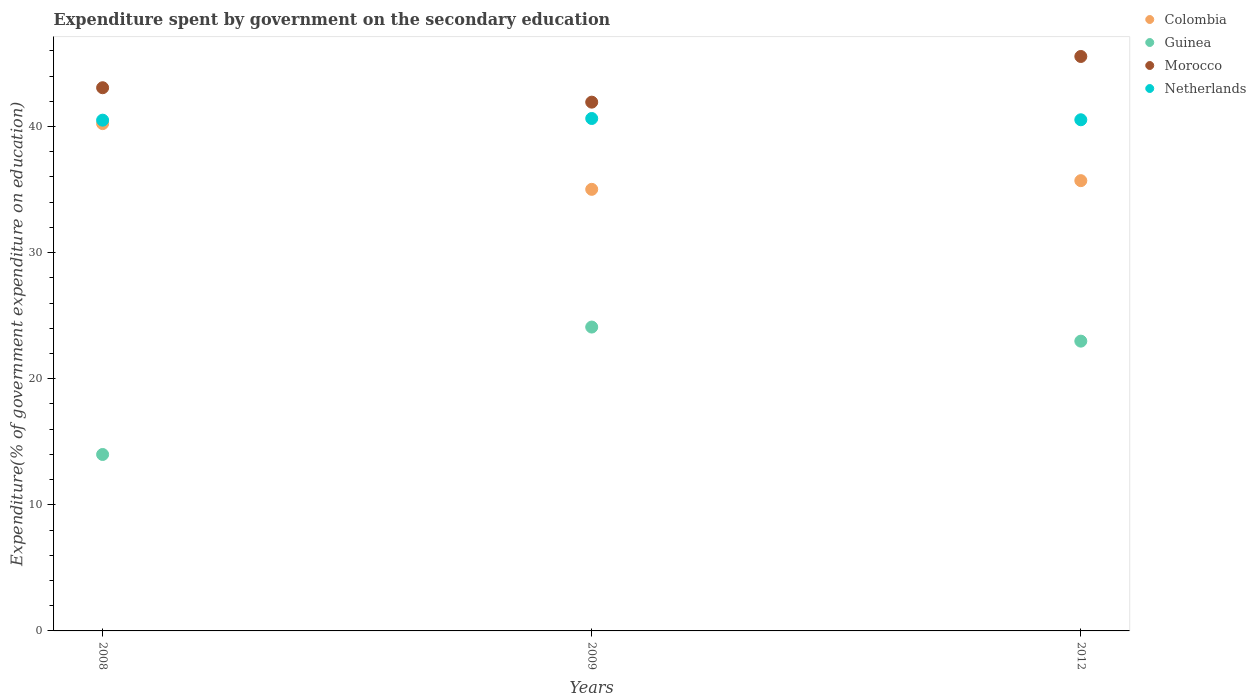Is the number of dotlines equal to the number of legend labels?
Your answer should be very brief. Yes. What is the expenditure spent by government on the secondary education in Morocco in 2009?
Provide a succinct answer. 41.93. Across all years, what is the maximum expenditure spent by government on the secondary education in Colombia?
Offer a terse response. 40.23. Across all years, what is the minimum expenditure spent by government on the secondary education in Netherlands?
Offer a very short reply. 40.5. In which year was the expenditure spent by government on the secondary education in Colombia maximum?
Offer a very short reply. 2008. In which year was the expenditure spent by government on the secondary education in Morocco minimum?
Offer a very short reply. 2009. What is the total expenditure spent by government on the secondary education in Netherlands in the graph?
Your answer should be compact. 121.66. What is the difference between the expenditure spent by government on the secondary education in Morocco in 2008 and that in 2012?
Ensure brevity in your answer.  -2.48. What is the difference between the expenditure spent by government on the secondary education in Netherlands in 2012 and the expenditure spent by government on the secondary education in Guinea in 2008?
Give a very brief answer. 26.54. What is the average expenditure spent by government on the secondary education in Guinea per year?
Offer a very short reply. 20.35. In the year 2008, what is the difference between the expenditure spent by government on the secondary education in Netherlands and expenditure spent by government on the secondary education in Guinea?
Offer a very short reply. 26.51. What is the ratio of the expenditure spent by government on the secondary education in Guinea in 2008 to that in 2009?
Your answer should be very brief. 0.58. Is the expenditure spent by government on the secondary education in Netherlands in 2008 less than that in 2009?
Provide a short and direct response. Yes. What is the difference between the highest and the second highest expenditure spent by government on the secondary education in Netherlands?
Offer a very short reply. 0.1. What is the difference between the highest and the lowest expenditure spent by government on the secondary education in Morocco?
Provide a short and direct response. 3.62. Is the sum of the expenditure spent by government on the secondary education in Guinea in 2008 and 2012 greater than the maximum expenditure spent by government on the secondary education in Colombia across all years?
Your response must be concise. No. Is the expenditure spent by government on the secondary education in Colombia strictly greater than the expenditure spent by government on the secondary education in Morocco over the years?
Your answer should be compact. No. What is the difference between two consecutive major ticks on the Y-axis?
Your answer should be compact. 10. Does the graph contain any zero values?
Your answer should be very brief. No. Does the graph contain grids?
Your response must be concise. No. Where does the legend appear in the graph?
Offer a terse response. Top right. What is the title of the graph?
Your answer should be very brief. Expenditure spent by government on the secondary education. What is the label or title of the X-axis?
Keep it short and to the point. Years. What is the label or title of the Y-axis?
Provide a short and direct response. Expenditure(% of government expenditure on education). What is the Expenditure(% of government expenditure on education) of Colombia in 2008?
Ensure brevity in your answer.  40.23. What is the Expenditure(% of government expenditure on education) of Guinea in 2008?
Your answer should be very brief. 13.99. What is the Expenditure(% of government expenditure on education) in Morocco in 2008?
Offer a very short reply. 43.07. What is the Expenditure(% of government expenditure on education) of Netherlands in 2008?
Provide a short and direct response. 40.5. What is the Expenditure(% of government expenditure on education) in Colombia in 2009?
Ensure brevity in your answer.  35.01. What is the Expenditure(% of government expenditure on education) in Guinea in 2009?
Ensure brevity in your answer.  24.09. What is the Expenditure(% of government expenditure on education) in Morocco in 2009?
Your answer should be compact. 41.93. What is the Expenditure(% of government expenditure on education) in Netherlands in 2009?
Your response must be concise. 40.63. What is the Expenditure(% of government expenditure on education) of Colombia in 2012?
Provide a succinct answer. 35.7. What is the Expenditure(% of government expenditure on education) of Guinea in 2012?
Offer a terse response. 22.98. What is the Expenditure(% of government expenditure on education) of Morocco in 2012?
Keep it short and to the point. 45.55. What is the Expenditure(% of government expenditure on education) in Netherlands in 2012?
Keep it short and to the point. 40.53. Across all years, what is the maximum Expenditure(% of government expenditure on education) in Colombia?
Provide a short and direct response. 40.23. Across all years, what is the maximum Expenditure(% of government expenditure on education) in Guinea?
Give a very brief answer. 24.09. Across all years, what is the maximum Expenditure(% of government expenditure on education) in Morocco?
Your response must be concise. 45.55. Across all years, what is the maximum Expenditure(% of government expenditure on education) in Netherlands?
Offer a very short reply. 40.63. Across all years, what is the minimum Expenditure(% of government expenditure on education) in Colombia?
Give a very brief answer. 35.01. Across all years, what is the minimum Expenditure(% of government expenditure on education) in Guinea?
Your answer should be very brief. 13.99. Across all years, what is the minimum Expenditure(% of government expenditure on education) in Morocco?
Your answer should be compact. 41.93. Across all years, what is the minimum Expenditure(% of government expenditure on education) of Netherlands?
Your answer should be very brief. 40.5. What is the total Expenditure(% of government expenditure on education) in Colombia in the graph?
Keep it short and to the point. 110.94. What is the total Expenditure(% of government expenditure on education) in Guinea in the graph?
Keep it short and to the point. 61.06. What is the total Expenditure(% of government expenditure on education) of Morocco in the graph?
Offer a very short reply. 130.55. What is the total Expenditure(% of government expenditure on education) in Netherlands in the graph?
Your response must be concise. 121.66. What is the difference between the Expenditure(% of government expenditure on education) of Colombia in 2008 and that in 2009?
Your answer should be very brief. 5.21. What is the difference between the Expenditure(% of government expenditure on education) of Guinea in 2008 and that in 2009?
Keep it short and to the point. -10.1. What is the difference between the Expenditure(% of government expenditure on education) of Morocco in 2008 and that in 2009?
Offer a very short reply. 1.14. What is the difference between the Expenditure(% of government expenditure on education) in Netherlands in 2008 and that in 2009?
Provide a succinct answer. -0.13. What is the difference between the Expenditure(% of government expenditure on education) in Colombia in 2008 and that in 2012?
Your answer should be very brief. 4.52. What is the difference between the Expenditure(% of government expenditure on education) of Guinea in 2008 and that in 2012?
Provide a short and direct response. -8.99. What is the difference between the Expenditure(% of government expenditure on education) in Morocco in 2008 and that in 2012?
Make the answer very short. -2.48. What is the difference between the Expenditure(% of government expenditure on education) of Netherlands in 2008 and that in 2012?
Your response must be concise. -0.03. What is the difference between the Expenditure(% of government expenditure on education) of Colombia in 2009 and that in 2012?
Your answer should be compact. -0.69. What is the difference between the Expenditure(% of government expenditure on education) of Guinea in 2009 and that in 2012?
Offer a terse response. 1.12. What is the difference between the Expenditure(% of government expenditure on education) of Morocco in 2009 and that in 2012?
Your answer should be very brief. -3.62. What is the difference between the Expenditure(% of government expenditure on education) of Netherlands in 2009 and that in 2012?
Provide a succinct answer. 0.1. What is the difference between the Expenditure(% of government expenditure on education) in Colombia in 2008 and the Expenditure(% of government expenditure on education) in Guinea in 2009?
Offer a terse response. 16.13. What is the difference between the Expenditure(% of government expenditure on education) in Colombia in 2008 and the Expenditure(% of government expenditure on education) in Morocco in 2009?
Keep it short and to the point. -1.7. What is the difference between the Expenditure(% of government expenditure on education) of Colombia in 2008 and the Expenditure(% of government expenditure on education) of Netherlands in 2009?
Keep it short and to the point. -0.41. What is the difference between the Expenditure(% of government expenditure on education) in Guinea in 2008 and the Expenditure(% of government expenditure on education) in Morocco in 2009?
Your response must be concise. -27.94. What is the difference between the Expenditure(% of government expenditure on education) in Guinea in 2008 and the Expenditure(% of government expenditure on education) in Netherlands in 2009?
Your response must be concise. -26.64. What is the difference between the Expenditure(% of government expenditure on education) in Morocco in 2008 and the Expenditure(% of government expenditure on education) in Netherlands in 2009?
Offer a terse response. 2.44. What is the difference between the Expenditure(% of government expenditure on education) in Colombia in 2008 and the Expenditure(% of government expenditure on education) in Guinea in 2012?
Your response must be concise. 17.25. What is the difference between the Expenditure(% of government expenditure on education) of Colombia in 2008 and the Expenditure(% of government expenditure on education) of Morocco in 2012?
Provide a succinct answer. -5.32. What is the difference between the Expenditure(% of government expenditure on education) in Colombia in 2008 and the Expenditure(% of government expenditure on education) in Netherlands in 2012?
Keep it short and to the point. -0.3. What is the difference between the Expenditure(% of government expenditure on education) of Guinea in 2008 and the Expenditure(% of government expenditure on education) of Morocco in 2012?
Your answer should be very brief. -31.56. What is the difference between the Expenditure(% of government expenditure on education) in Guinea in 2008 and the Expenditure(% of government expenditure on education) in Netherlands in 2012?
Ensure brevity in your answer.  -26.54. What is the difference between the Expenditure(% of government expenditure on education) of Morocco in 2008 and the Expenditure(% of government expenditure on education) of Netherlands in 2012?
Provide a succinct answer. 2.54. What is the difference between the Expenditure(% of government expenditure on education) of Colombia in 2009 and the Expenditure(% of government expenditure on education) of Guinea in 2012?
Your answer should be compact. 12.04. What is the difference between the Expenditure(% of government expenditure on education) of Colombia in 2009 and the Expenditure(% of government expenditure on education) of Morocco in 2012?
Your response must be concise. -10.54. What is the difference between the Expenditure(% of government expenditure on education) of Colombia in 2009 and the Expenditure(% of government expenditure on education) of Netherlands in 2012?
Offer a terse response. -5.52. What is the difference between the Expenditure(% of government expenditure on education) of Guinea in 2009 and the Expenditure(% of government expenditure on education) of Morocco in 2012?
Your answer should be compact. -21.46. What is the difference between the Expenditure(% of government expenditure on education) in Guinea in 2009 and the Expenditure(% of government expenditure on education) in Netherlands in 2012?
Give a very brief answer. -16.44. What is the difference between the Expenditure(% of government expenditure on education) of Morocco in 2009 and the Expenditure(% of government expenditure on education) of Netherlands in 2012?
Keep it short and to the point. 1.4. What is the average Expenditure(% of government expenditure on education) in Colombia per year?
Your response must be concise. 36.98. What is the average Expenditure(% of government expenditure on education) of Guinea per year?
Give a very brief answer. 20.35. What is the average Expenditure(% of government expenditure on education) in Morocco per year?
Give a very brief answer. 43.52. What is the average Expenditure(% of government expenditure on education) of Netherlands per year?
Your response must be concise. 40.55. In the year 2008, what is the difference between the Expenditure(% of government expenditure on education) of Colombia and Expenditure(% of government expenditure on education) of Guinea?
Offer a terse response. 26.24. In the year 2008, what is the difference between the Expenditure(% of government expenditure on education) of Colombia and Expenditure(% of government expenditure on education) of Morocco?
Give a very brief answer. -2.85. In the year 2008, what is the difference between the Expenditure(% of government expenditure on education) of Colombia and Expenditure(% of government expenditure on education) of Netherlands?
Provide a short and direct response. -0.27. In the year 2008, what is the difference between the Expenditure(% of government expenditure on education) of Guinea and Expenditure(% of government expenditure on education) of Morocco?
Your answer should be very brief. -29.08. In the year 2008, what is the difference between the Expenditure(% of government expenditure on education) of Guinea and Expenditure(% of government expenditure on education) of Netherlands?
Your response must be concise. -26.51. In the year 2008, what is the difference between the Expenditure(% of government expenditure on education) of Morocco and Expenditure(% of government expenditure on education) of Netherlands?
Offer a very short reply. 2.57. In the year 2009, what is the difference between the Expenditure(% of government expenditure on education) in Colombia and Expenditure(% of government expenditure on education) in Guinea?
Your answer should be compact. 10.92. In the year 2009, what is the difference between the Expenditure(% of government expenditure on education) in Colombia and Expenditure(% of government expenditure on education) in Morocco?
Offer a terse response. -6.91. In the year 2009, what is the difference between the Expenditure(% of government expenditure on education) in Colombia and Expenditure(% of government expenditure on education) in Netherlands?
Make the answer very short. -5.62. In the year 2009, what is the difference between the Expenditure(% of government expenditure on education) of Guinea and Expenditure(% of government expenditure on education) of Morocco?
Give a very brief answer. -17.83. In the year 2009, what is the difference between the Expenditure(% of government expenditure on education) in Guinea and Expenditure(% of government expenditure on education) in Netherlands?
Ensure brevity in your answer.  -16.54. In the year 2009, what is the difference between the Expenditure(% of government expenditure on education) of Morocco and Expenditure(% of government expenditure on education) of Netherlands?
Your answer should be very brief. 1.3. In the year 2012, what is the difference between the Expenditure(% of government expenditure on education) of Colombia and Expenditure(% of government expenditure on education) of Guinea?
Offer a terse response. 12.72. In the year 2012, what is the difference between the Expenditure(% of government expenditure on education) in Colombia and Expenditure(% of government expenditure on education) in Morocco?
Make the answer very short. -9.85. In the year 2012, what is the difference between the Expenditure(% of government expenditure on education) of Colombia and Expenditure(% of government expenditure on education) of Netherlands?
Give a very brief answer. -4.83. In the year 2012, what is the difference between the Expenditure(% of government expenditure on education) in Guinea and Expenditure(% of government expenditure on education) in Morocco?
Offer a very short reply. -22.57. In the year 2012, what is the difference between the Expenditure(% of government expenditure on education) in Guinea and Expenditure(% of government expenditure on education) in Netherlands?
Provide a succinct answer. -17.55. In the year 2012, what is the difference between the Expenditure(% of government expenditure on education) in Morocco and Expenditure(% of government expenditure on education) in Netherlands?
Provide a short and direct response. 5.02. What is the ratio of the Expenditure(% of government expenditure on education) in Colombia in 2008 to that in 2009?
Provide a succinct answer. 1.15. What is the ratio of the Expenditure(% of government expenditure on education) in Guinea in 2008 to that in 2009?
Keep it short and to the point. 0.58. What is the ratio of the Expenditure(% of government expenditure on education) in Morocco in 2008 to that in 2009?
Offer a terse response. 1.03. What is the ratio of the Expenditure(% of government expenditure on education) in Netherlands in 2008 to that in 2009?
Your response must be concise. 1. What is the ratio of the Expenditure(% of government expenditure on education) of Colombia in 2008 to that in 2012?
Provide a short and direct response. 1.13. What is the ratio of the Expenditure(% of government expenditure on education) of Guinea in 2008 to that in 2012?
Make the answer very short. 0.61. What is the ratio of the Expenditure(% of government expenditure on education) of Morocco in 2008 to that in 2012?
Your answer should be very brief. 0.95. What is the ratio of the Expenditure(% of government expenditure on education) of Colombia in 2009 to that in 2012?
Provide a short and direct response. 0.98. What is the ratio of the Expenditure(% of government expenditure on education) in Guinea in 2009 to that in 2012?
Your answer should be very brief. 1.05. What is the ratio of the Expenditure(% of government expenditure on education) of Morocco in 2009 to that in 2012?
Provide a succinct answer. 0.92. What is the difference between the highest and the second highest Expenditure(% of government expenditure on education) of Colombia?
Provide a succinct answer. 4.52. What is the difference between the highest and the second highest Expenditure(% of government expenditure on education) of Guinea?
Your answer should be compact. 1.12. What is the difference between the highest and the second highest Expenditure(% of government expenditure on education) of Morocco?
Your answer should be compact. 2.48. What is the difference between the highest and the second highest Expenditure(% of government expenditure on education) in Netherlands?
Ensure brevity in your answer.  0.1. What is the difference between the highest and the lowest Expenditure(% of government expenditure on education) in Colombia?
Your answer should be compact. 5.21. What is the difference between the highest and the lowest Expenditure(% of government expenditure on education) in Guinea?
Offer a very short reply. 10.1. What is the difference between the highest and the lowest Expenditure(% of government expenditure on education) of Morocco?
Offer a very short reply. 3.62. What is the difference between the highest and the lowest Expenditure(% of government expenditure on education) of Netherlands?
Provide a succinct answer. 0.13. 